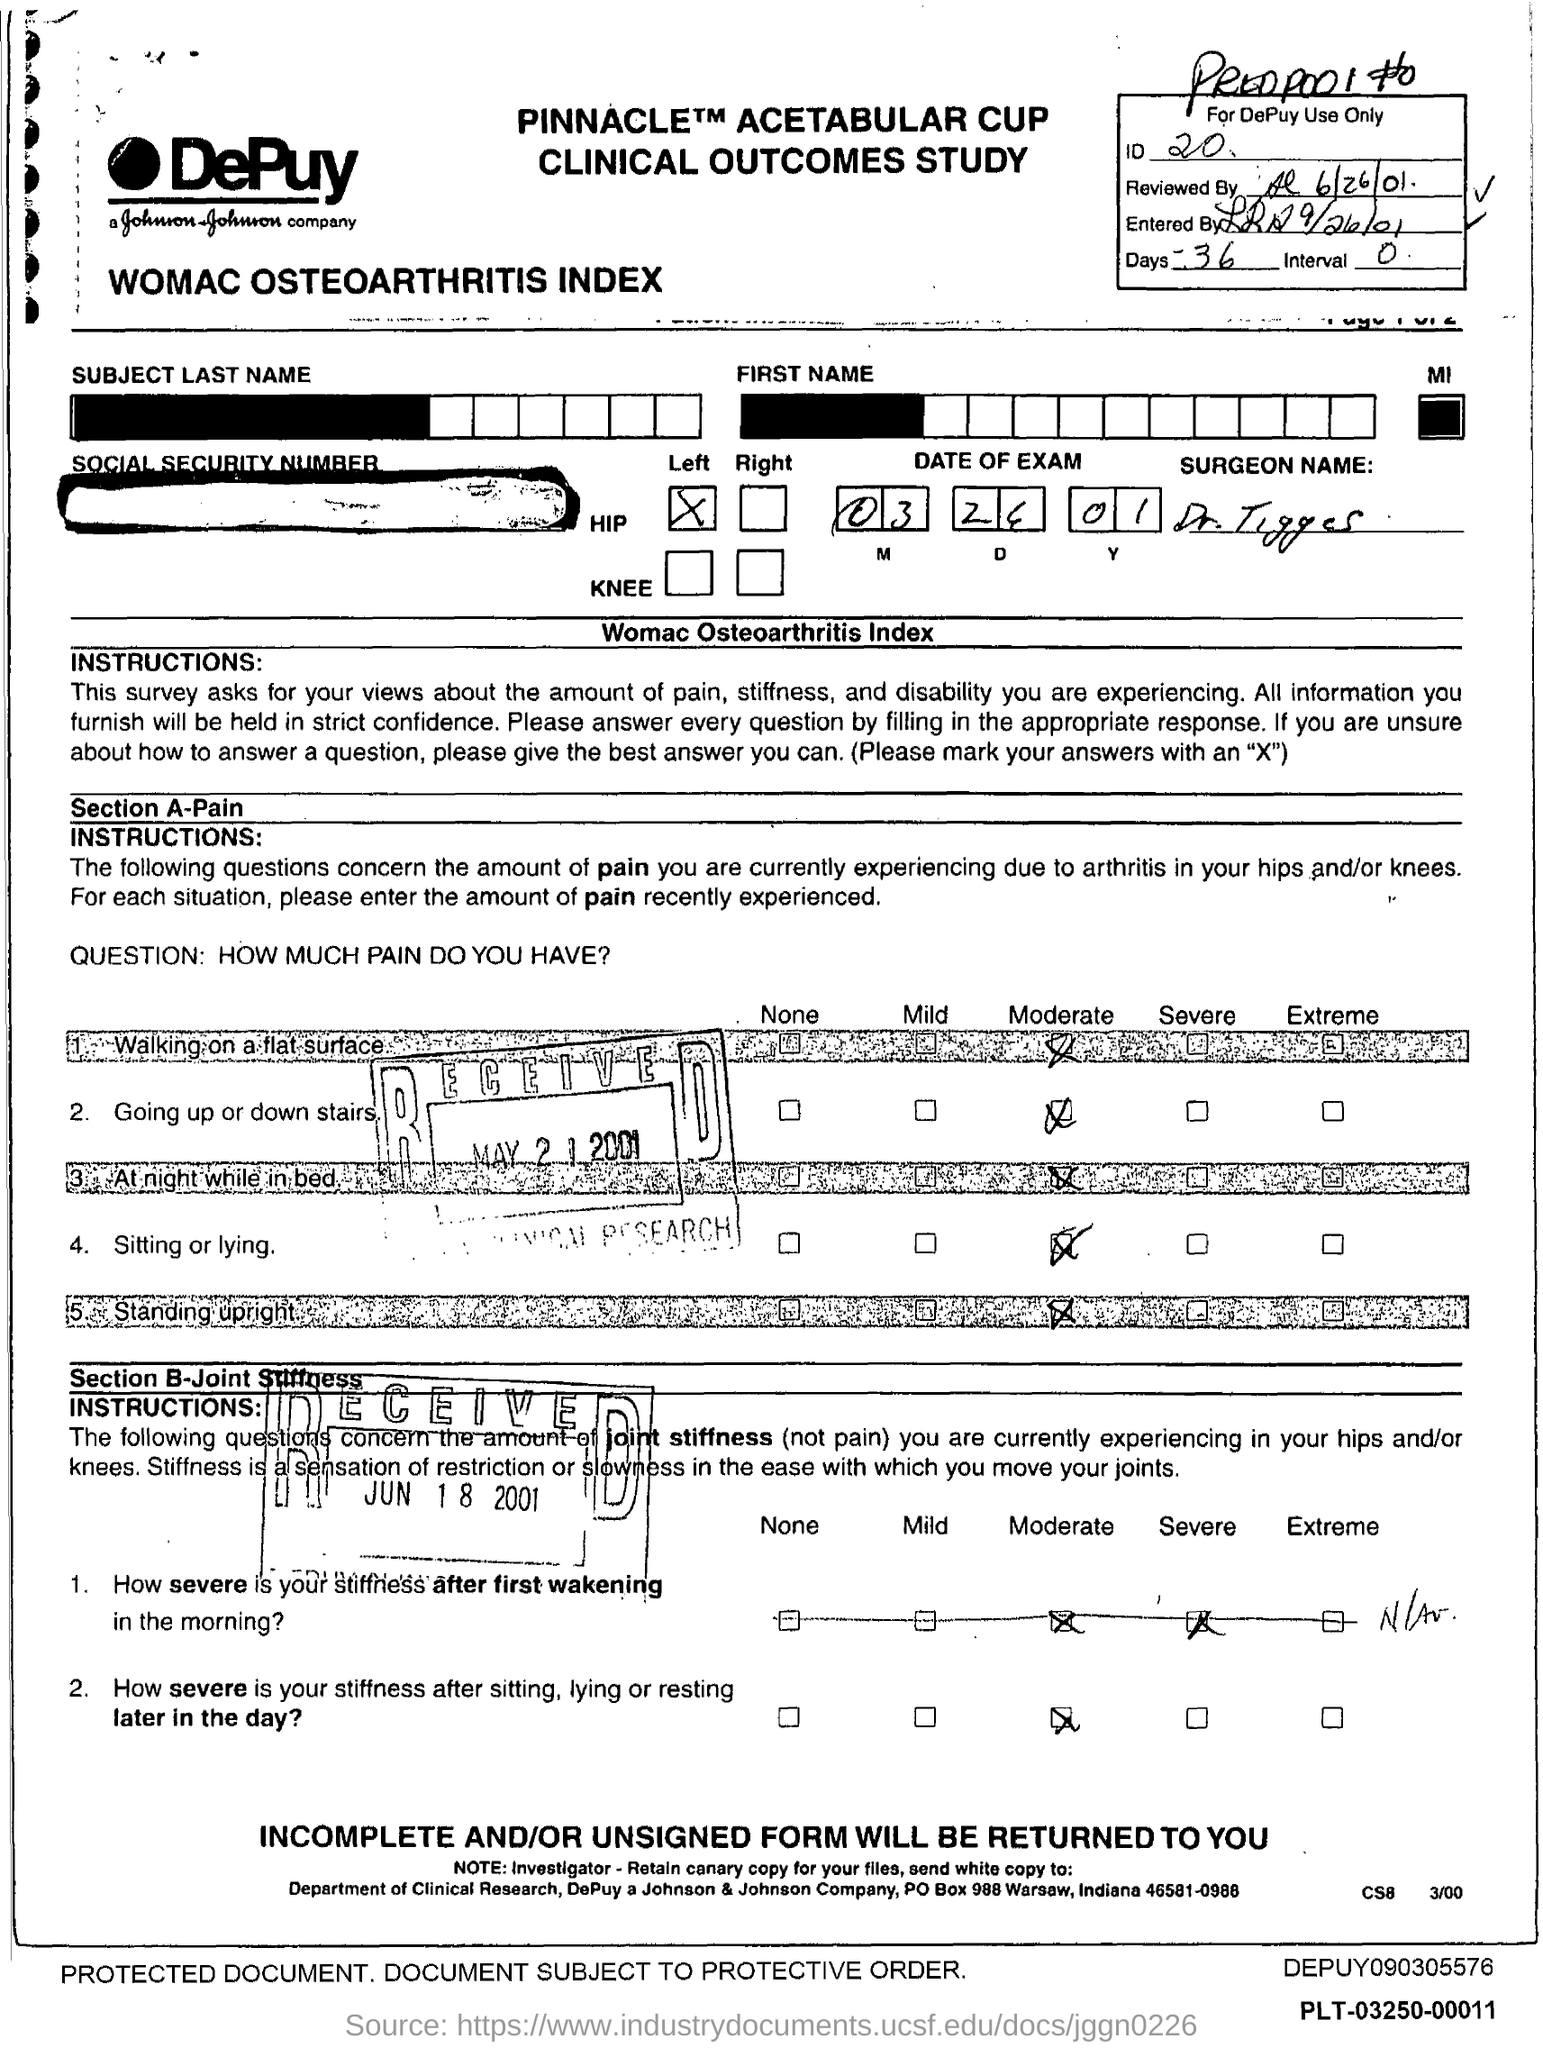What is the ID mentioned in the form?
Ensure brevity in your answer.  20. What is the no of days given in the form?
Offer a terse response. 36. What is the interval mentioned in the form?
Provide a short and direct response. 0. 